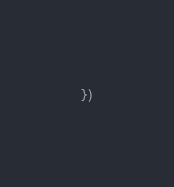Convert code to text. <code><loc_0><loc_0><loc_500><loc_500><_JavaScript_>})</code> 